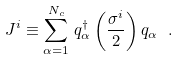<formula> <loc_0><loc_0><loc_500><loc_500>J ^ { i } \equiv \sum _ { \alpha = 1 } ^ { N _ { c } } \, q ^ { \dagger } _ { \alpha } \left ( \frac { \sigma ^ { i } } { 2 } \right ) q _ { \alpha } \ .</formula> 